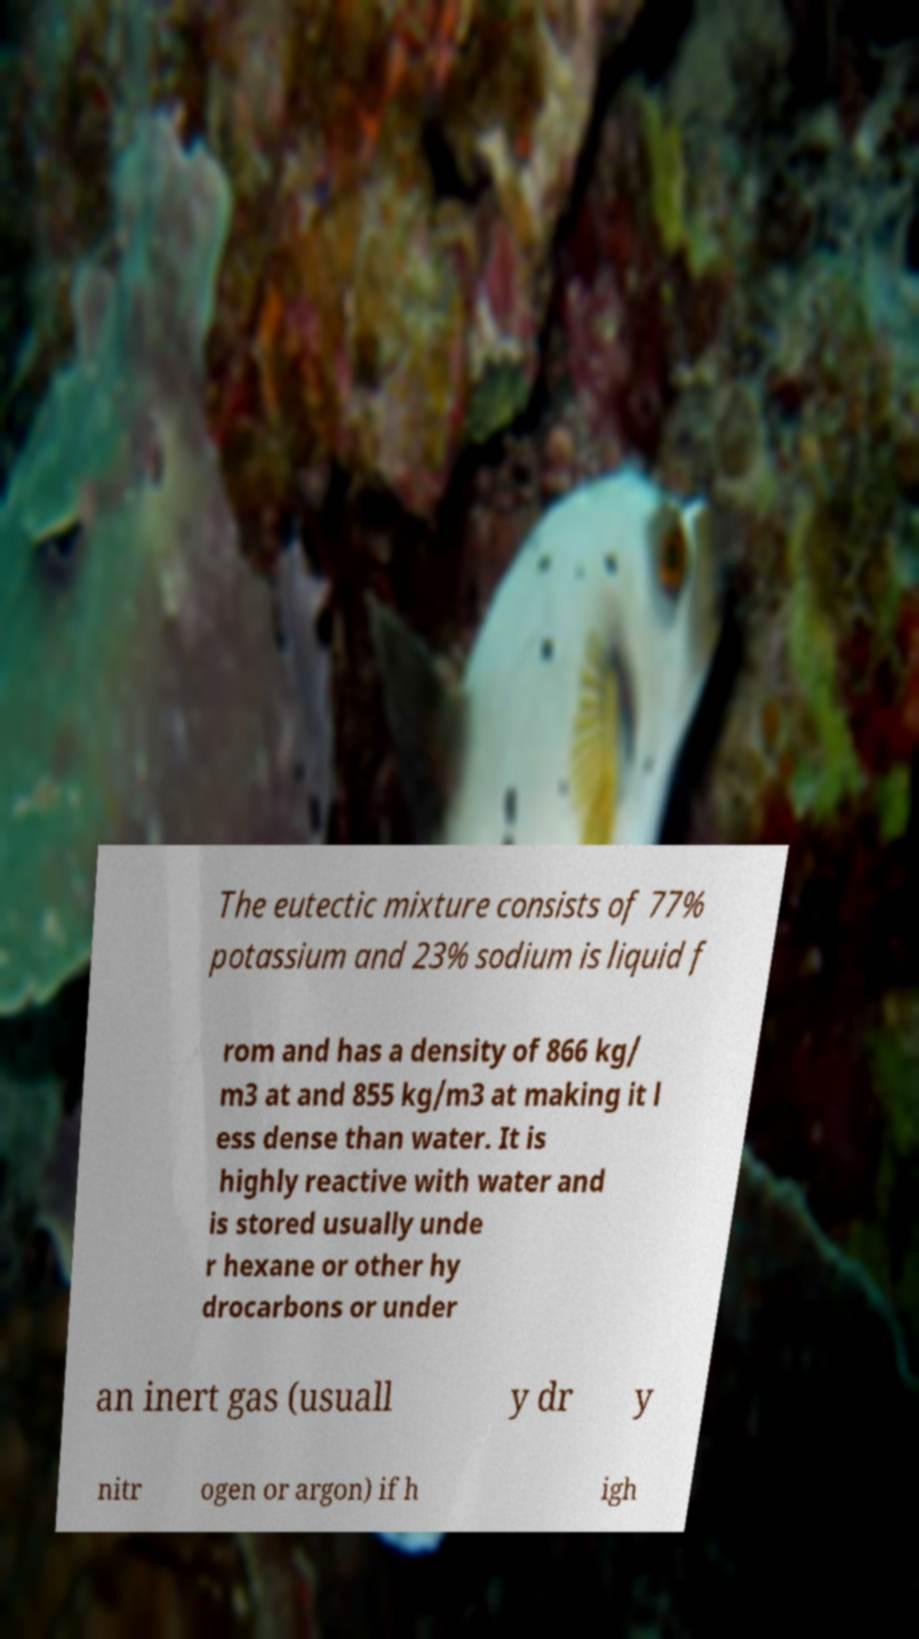Could you extract and type out the text from this image? The eutectic mixture consists of 77% potassium and 23% sodium is liquid f rom and has a density of 866 kg/ m3 at and 855 kg/m3 at making it l ess dense than water. It is highly reactive with water and is stored usually unde r hexane or other hy drocarbons or under an inert gas (usuall y dr y nitr ogen or argon) if h igh 